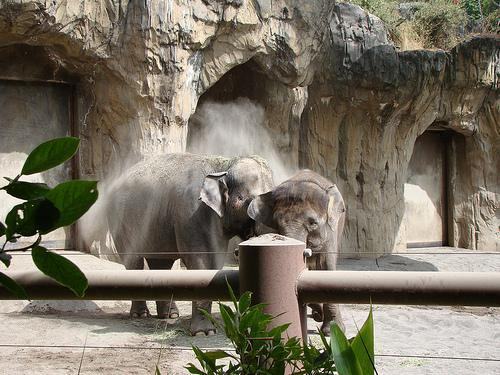In a concise manner, describe the picture's main subjects and the environment they are in. The image portrays two elephants of different sizes in a zoo enclosure with metal railing and green foliage. Briefly describe the main focus of the image. Two elephants are in an enclosure at a zoo, surrounded by green leaves and a metal fence. Quickly list the main features of the image and the interactions between them. Features: elephants, enclosure, green leaves, metal fence, waterfall. The elephants are inside the enclosure with leaves around them and the waterfall behind. Sum up the main scene depicted in the image, focusing on the primary subjects and their environment. The image showcases a pair of elephants in a zoo enclosure surrounded by green leaves, a metal fence, and with a waterfall in the backdrop. Describe the main components and setting of the picture concisely. In the image, a pair of elephants are enclosed in a zoo with green leaves and a fence, and there's a waterfall nearby. State the primary elements in the image and their interactions. A pair of elephants are in an enclosure with green foliage, and there's a waterfall in the background. Write a brief summary of what's happening in the image. The image shows two elephants in a zoo enclosure while surrounded by green leaves and a metal fence, with a waterfall in the background. Enumerate the primary elements of the image, and briefly explain their arrangement. Key elements: Two elephants standing together, a metal fence, green leaves, and a waterfall. The elephants are inside the fence with green leaves around and the waterfall behind them. In a few words, describe the main subjects in the image and what they are doing. The main subjects are two elephants standing inside a zoo enclosure with green leaves and a metal fence near a waterfall. Provide a short description of the primary objects and setting of the image. Two elephants are standing in a zoo enclosure, surrounded by green leaves, a metal fence, and with a waterfall in the background. 